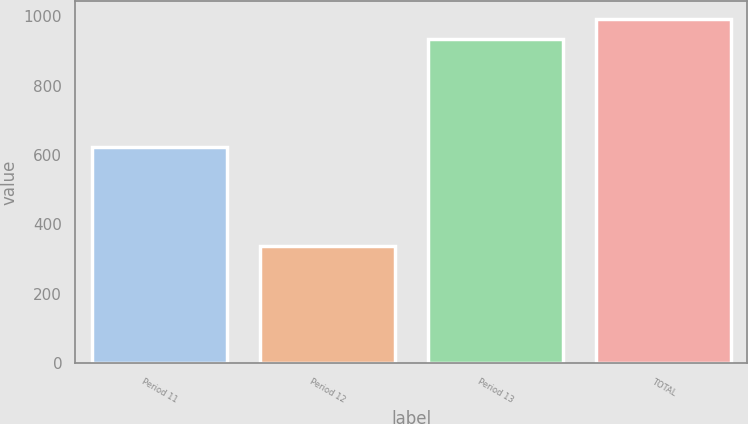Convert chart. <chart><loc_0><loc_0><loc_500><loc_500><bar_chart><fcel>Period 11<fcel>Period 12<fcel>Period 13<fcel>TOTAL<nl><fcel>623<fcel>338<fcel>933<fcel>992.5<nl></chart> 